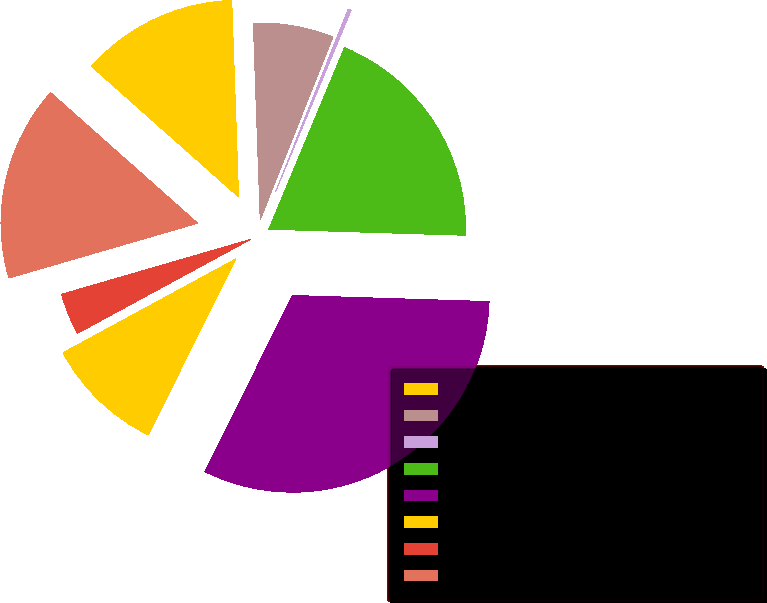Convert chart. <chart><loc_0><loc_0><loc_500><loc_500><pie_chart><fcel>Product Type<fcel>Interest rate contracts<fcel>Credit contracts<fcel>Foreign exchange contracts<fcel>Equity contracts<fcel>Commodity contracts<fcel>Other contracts<fcel>Total derivative instruments<nl><fcel>12.89%<fcel>6.58%<fcel>0.26%<fcel>19.21%<fcel>31.85%<fcel>9.74%<fcel>3.42%<fcel>16.05%<nl></chart> 